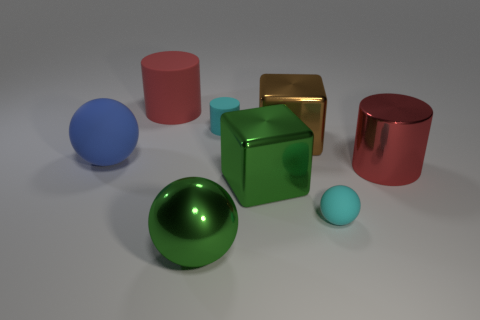Can you infer anything about the atmosphere or setting from this image? The image suggests a controlled environment, possibly a studio setup, where objects are deliberately placed for either artistic expression, a product showcase, or a rendering test. The absence of any background elements or distractive details points to a focus on the objects and their interplay with light. 